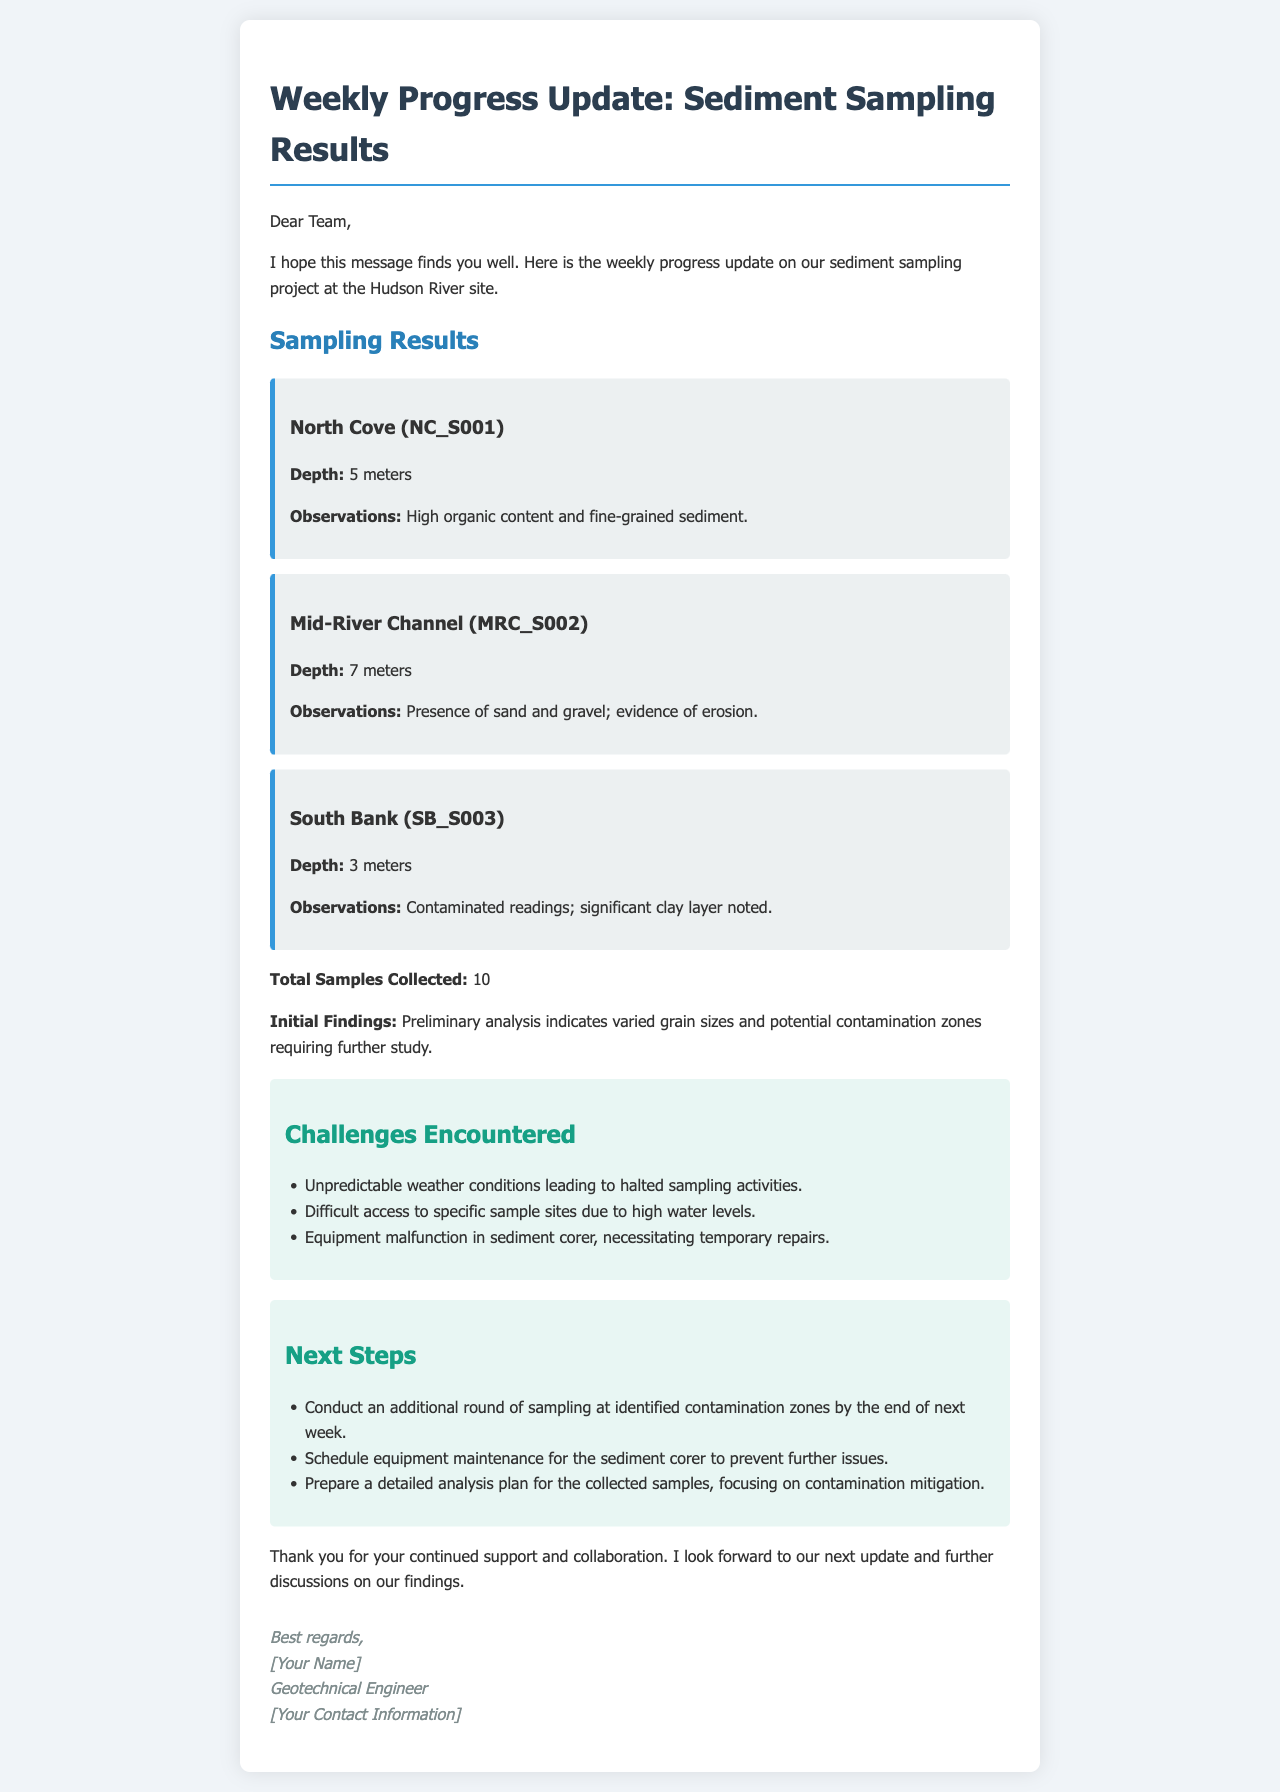what is the depth of the North Cove sample? The depth of the North Cove sample is mentioned in the observations section, which states it is 5 meters.
Answer: 5 meters how many total samples were collected? The document explicitly states the total number of samples collected as ten.
Answer: 10 what was observed at the South Bank sampling location? The observations for the South Bank indicate there were contaminated readings and a significant clay layer noted.
Answer: Contaminated readings; significant clay layer noted what is one challenge faced during sediment sampling? The document lists several challenges; one of them is unpredictable weather conditions leading to halted sampling activities.
Answer: Unpredictable weather conditions what will be scheduled for the sediment corer? The next steps call for scheduling equipment maintenance for the sediment corer to prevent further issues.
Answer: Equipment maintenance how many meters deep is the Mid-River Channel sample? The Mid-River Channel sample depth is specified in the document, which is noted as 7 meters.
Answer: 7 meters what is the focus of the detailed analysis plan for the collected samples? The focus of the detailed analysis plan mentioned in the next steps is primarily on the mitigation of contamination.
Answer: Contamination mitigation what specific problem was encountered with the sediment corer? The document mentions a malfunction in the sediment corer, requiring temporary repairs.
Answer: Equipment malfunction how many meters deep is the South Bank sample? The depth of the South Bank sample is noted as 3 meters in the sampling results section of the document.
Answer: 3 meters 